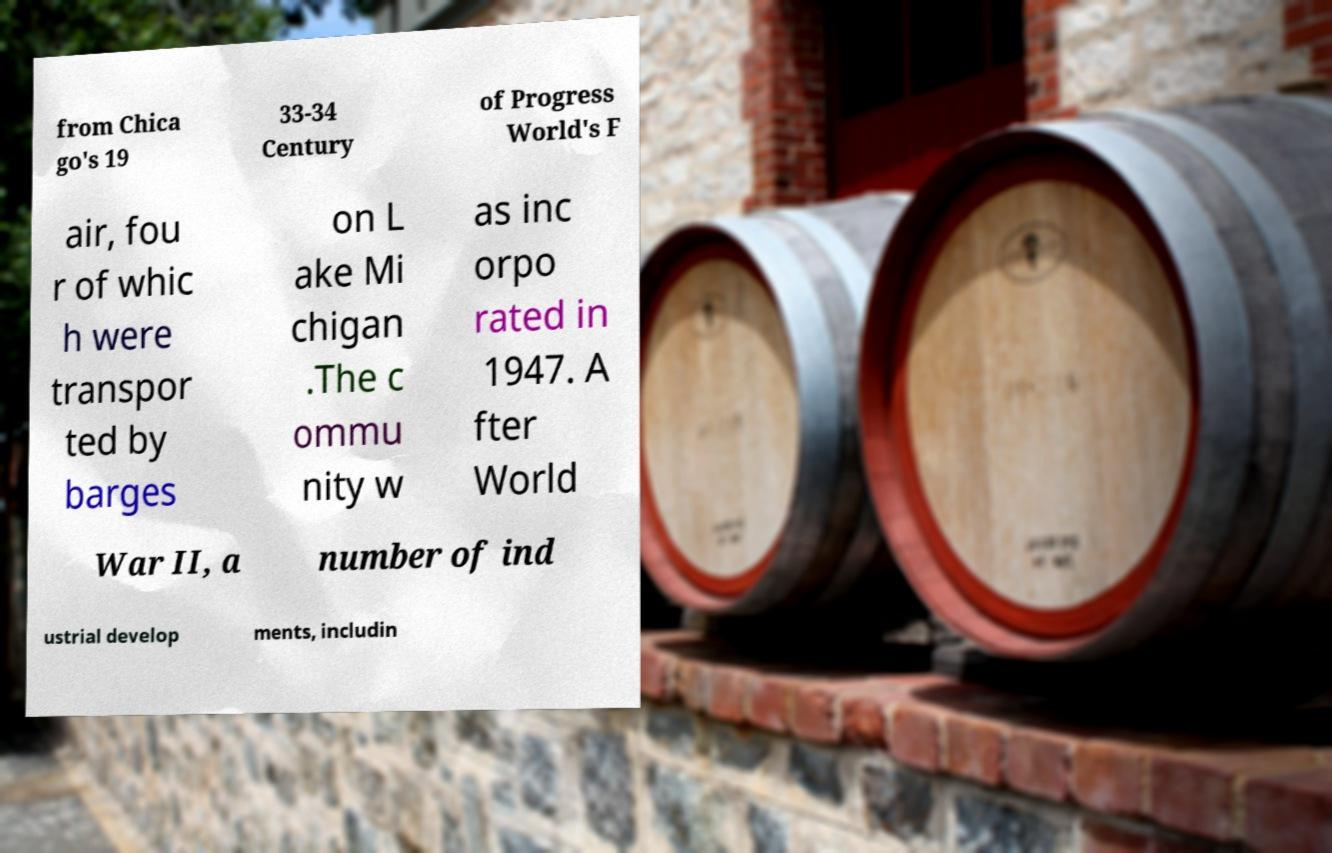Can you read and provide the text displayed in the image?This photo seems to have some interesting text. Can you extract and type it out for me? from Chica go's 19 33-34 Century of Progress World's F air, fou r of whic h were transpor ted by barges on L ake Mi chigan .The c ommu nity w as inc orpo rated in 1947. A fter World War II, a number of ind ustrial develop ments, includin 